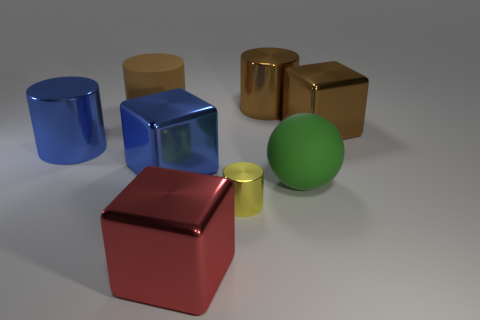Subtract all yellow shiny cylinders. How many cylinders are left? 3 Subtract all balls. How many objects are left? 7 Subtract 1 balls. How many balls are left? 0 Add 1 tiny cylinders. How many objects exist? 9 Subtract all yellow cylinders. How many cylinders are left? 3 Subtract 0 gray cylinders. How many objects are left? 8 Subtract all brown balls. Subtract all yellow blocks. How many balls are left? 1 Subtract all brown blocks. How many blue spheres are left? 0 Subtract all big things. Subtract all yellow metal things. How many objects are left? 0 Add 5 big green balls. How many big green balls are left? 6 